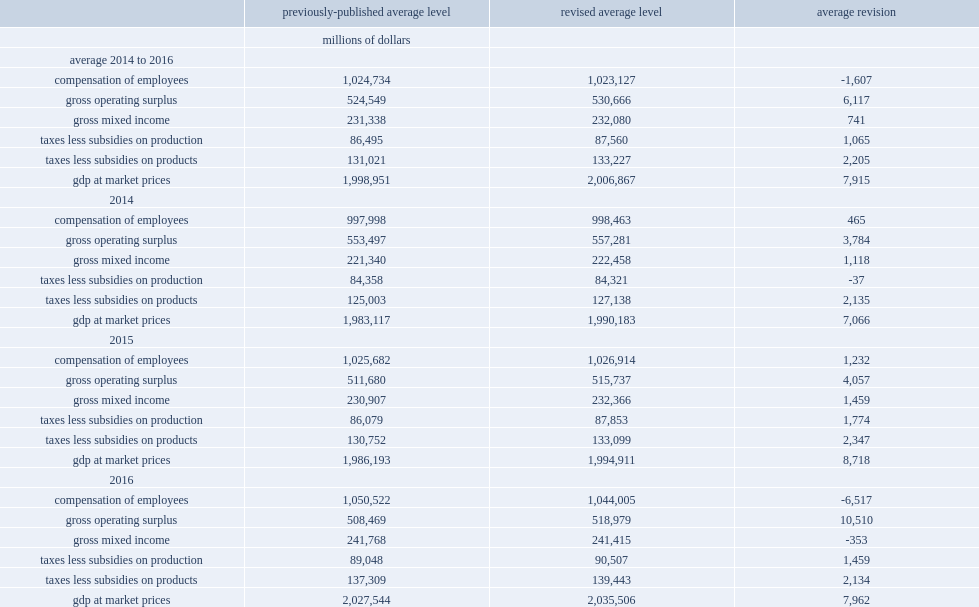What was the number of gross operating surplus adjusted upward by for 2014,2015 and 2016 respectively? 3784.0 4057.0 10510.0. Which year did estimates of gross mixed income revise up? 2014.0 2015.0. What was the number of taxes less subsidies on products and imports revised up by in all three years? 2205.0. 